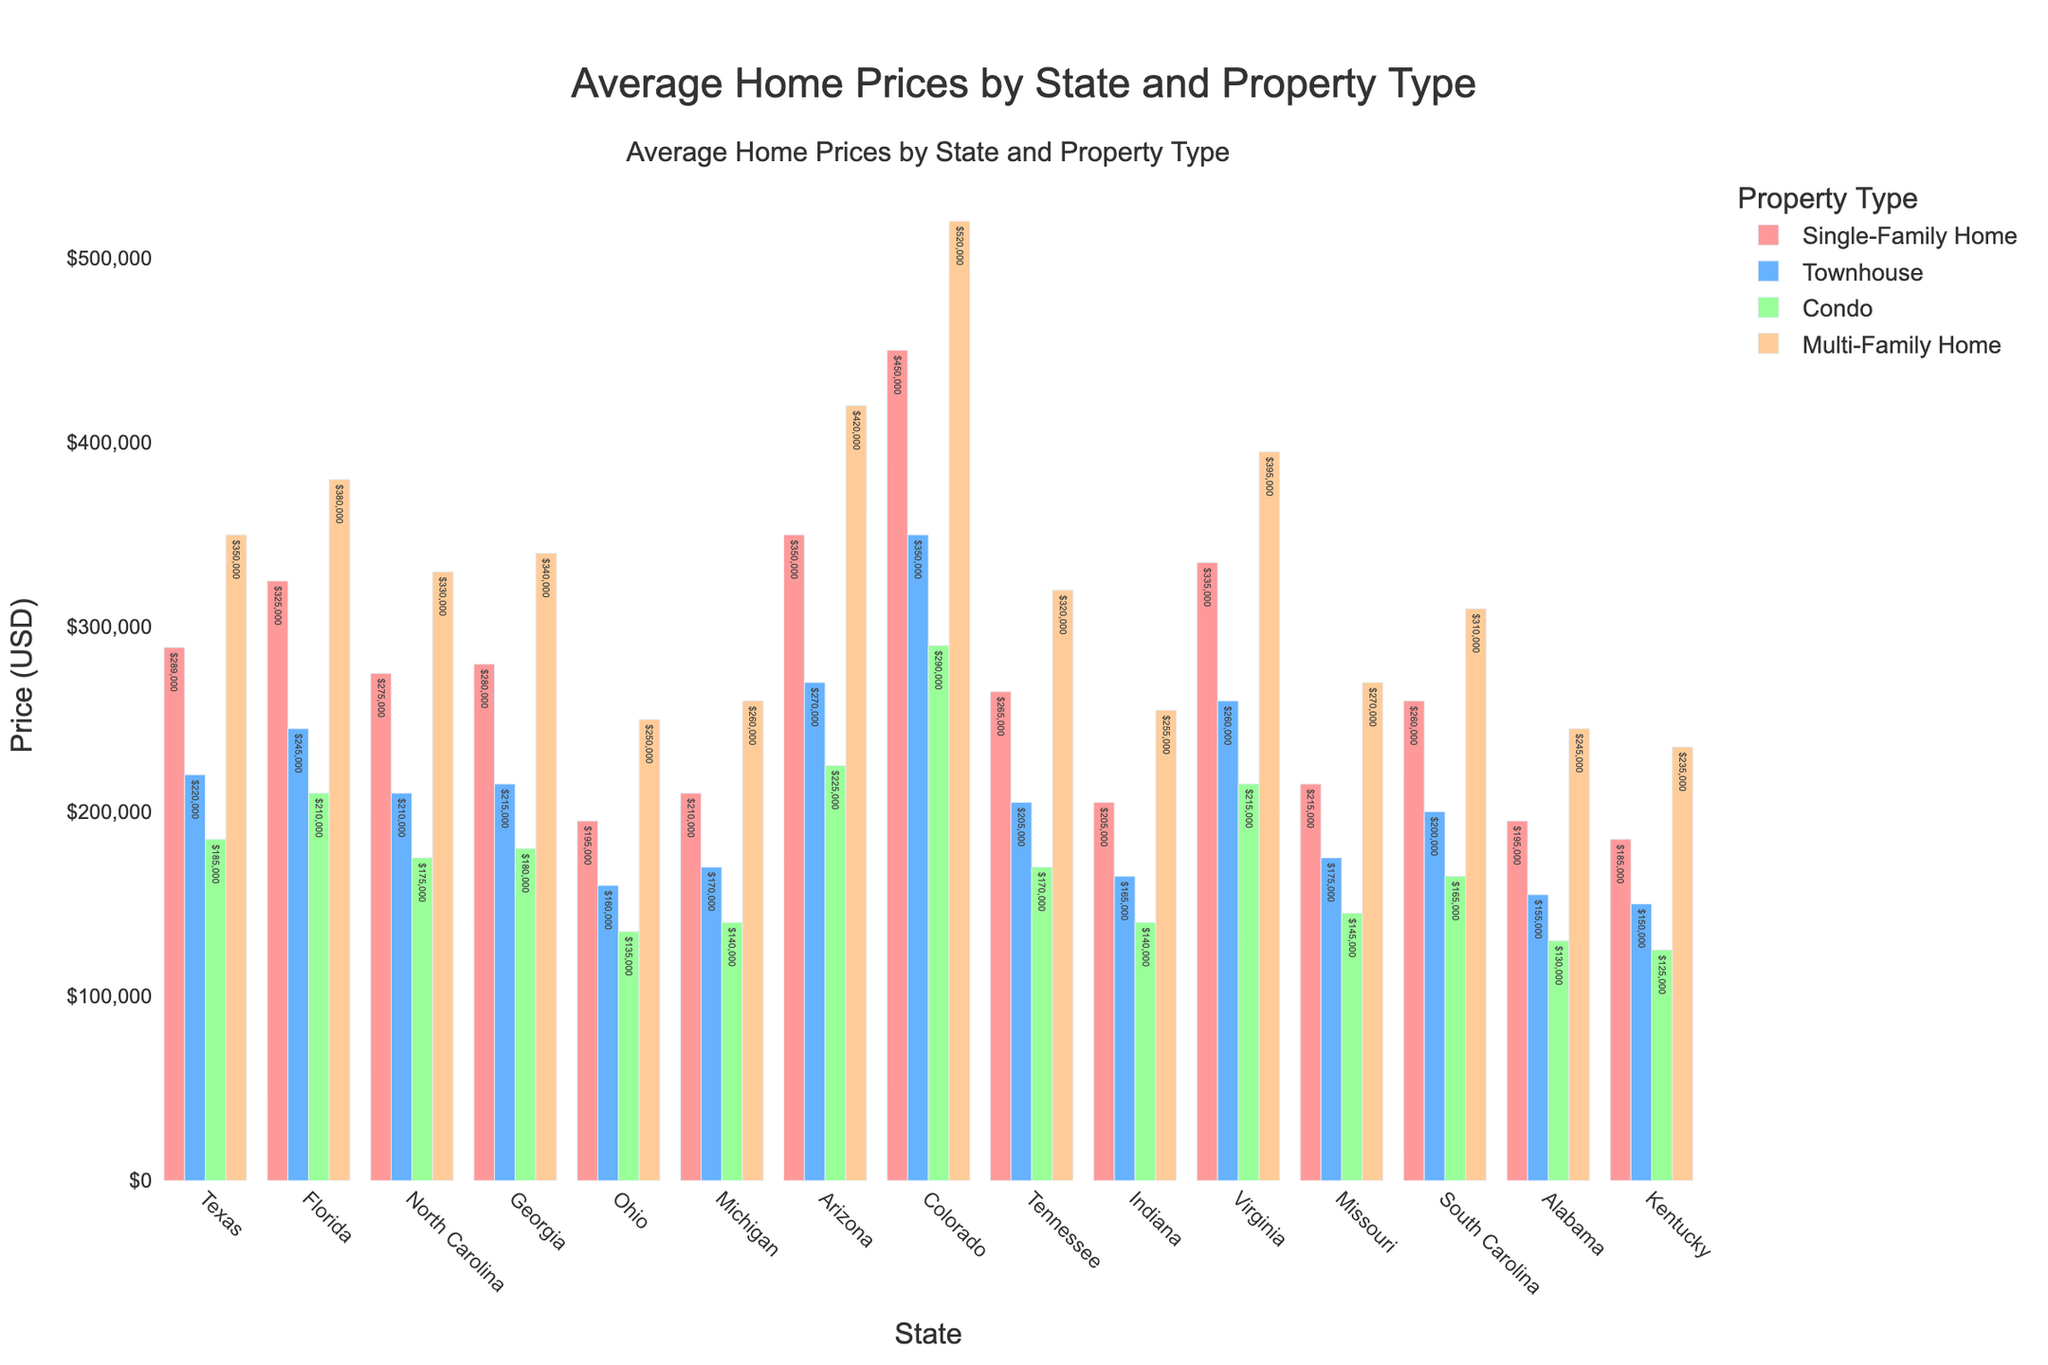Which state has the highest average price for a single-family home? Looking at the bar heights for single-family homes, Colorado has the tallest bar among all the states, indicating the highest average price.
Answer: Colorado Which property type in Arizona has the lowest average price? By comparing the bar heights for different property types in Arizona, the condo bar is the shortest among all, indicating the lowest average price.
Answer: Condo What is the difference in average prices between townhouses and multi-family homes in Texas? The average price for a townhouse in Texas is $220,000, and for multi-family homes, it’s $350,000. The difference is $350,000 - $220,000.
Answer: $130,000 Which two property types in North Carolina have the smallest price difference, and what is that difference? Comparing the prices for all property types in North Carolina, townhouses and condos have the smallest price difference. The difference is $210,000 - $175,000.
Answer: Townhouses and condos, $35,000 How does the average price of a single-family home in Virginia compare to a single-family home in Florida? Looking at the bars for single-family homes, Virginia has a price of $335,000, while Florida has $325,000. Virginia’s price is slightly higher.
Answer: Virginia's price is higher What is the average price of condos across Ohio, Michigan, and Indiana? Adding the prices of condos in Ohio ($135,000), Michigan ($140,000), and Indiana ($140,000) gives $415,000. Dividing by 3 states provides the average.
Answer: $138,333 How much more expensive is the average price of a multi-family home in Colorado compared to Alabama? The price of a multi-family home in Colorado is $520,000, and in Alabama, it’s $245,000. Subtracting these gives the price difference.
Answer: $275,000 What is the most expensive property type on average in Tennessee? The bar for multi-family homes in Tennessee is the tallest among all property types, indicating the highest average price.
Answer: Multi-family home Which state has the most uniform average prices across all property types? Observing the bar heights for each state to find the most similar heights across property types shows Kentucky’s bars are very close in height.
Answer: Kentucky 